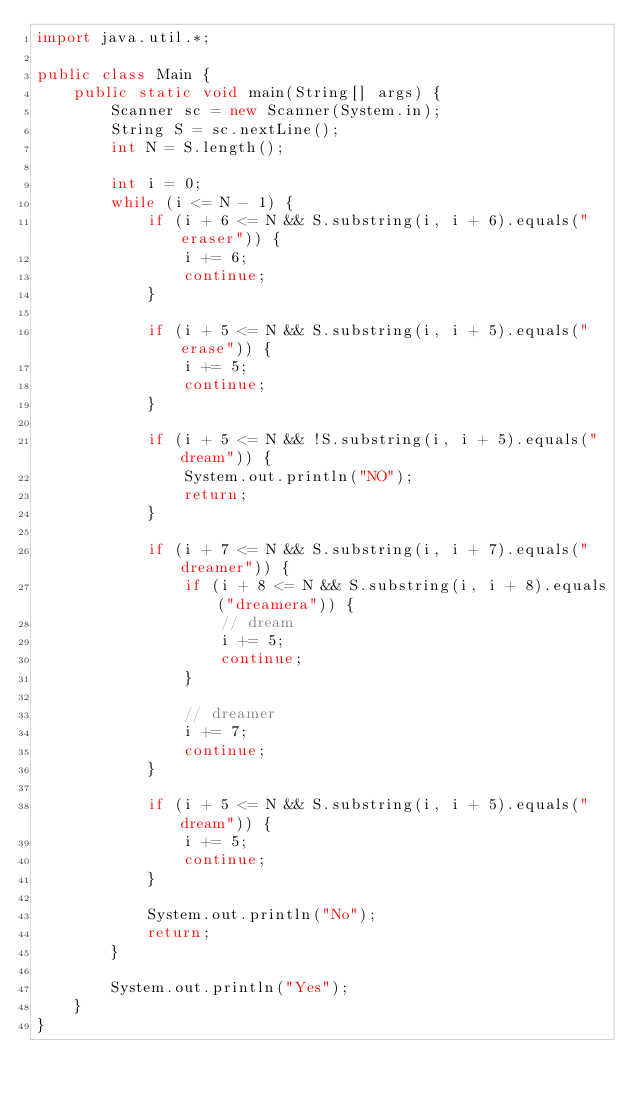<code> <loc_0><loc_0><loc_500><loc_500><_Java_>import java.util.*;

public class Main {
    public static void main(String[] args) {
        Scanner sc = new Scanner(System.in);
        String S = sc.nextLine();
        int N = S.length();

        int i = 0;
        while (i <= N - 1) {
            if (i + 6 <= N && S.substring(i, i + 6).equals("eraser")) {
                i += 6;
                continue;
            }

            if (i + 5 <= N && S.substring(i, i + 5).equals("erase")) {
                i += 5;
                continue;
            }

            if (i + 5 <= N && !S.substring(i, i + 5).equals("dream")) {
                System.out.println("NO");
                return;
            }

            if (i + 7 <= N && S.substring(i, i + 7).equals("dreamer")) {
                if (i + 8 <= N && S.substring(i, i + 8).equals("dreamera")) {
                    // dream
                    i += 5;
                    continue;
                }

                // dreamer
                i += 7;
                continue;
            }

            if (i + 5 <= N && S.substring(i, i + 5).equals("dream")) {
                i += 5;
                continue;
            }

            System.out.println("No");
            return;
        }

        System.out.println("Yes");
    }
}</code> 